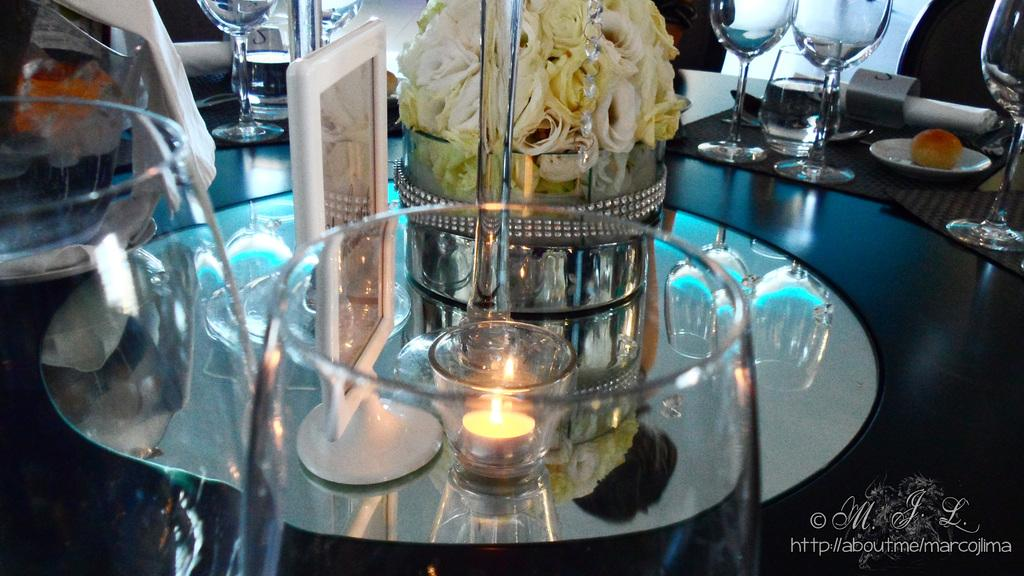What objects can be seen in the image that people might use for drinking? There are glasses in the image that people might use for drinking. What object in the image might provide light? There is a candle in the image that might provide light. What type of decorative items are present in the image? There are flowers in the image that can serve as decorative items. What type of humor can be found in the image? There is no humor present in the image; it features glasses, a candle, and flowers. Can you tell me how many geese are depicted in the image? There are no geese present in the image. 